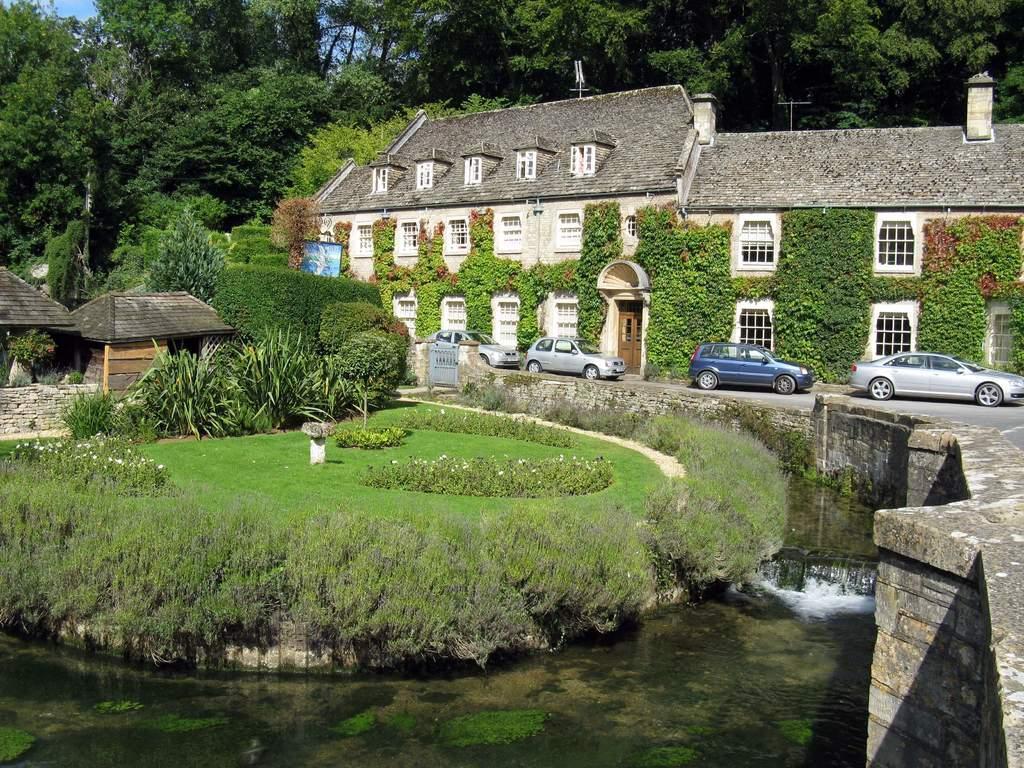In one or two sentences, can you explain what this image depicts? In the image there is a water surface in the foreground, behind that there is a garden with some plants and behind the garden there is a huge building, in front of the building there are cars and around the building there are a lot of trees. 